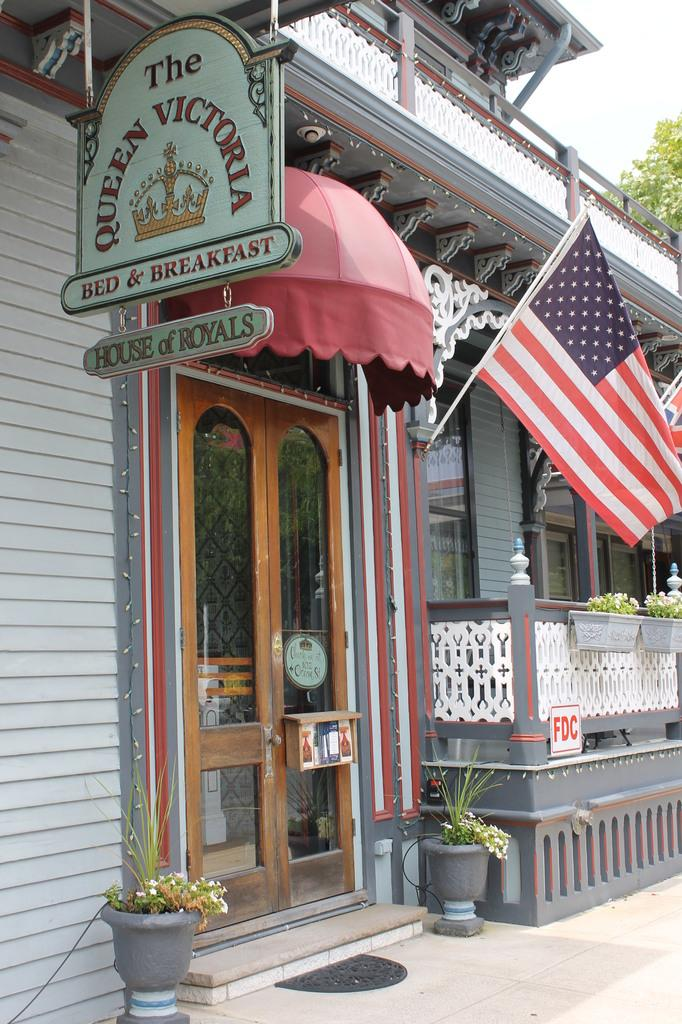<image>
Relay a brief, clear account of the picture shown. The ouside of the The Queen Victoria Bed and Breakfast House of Royals store with an American flag waving. 